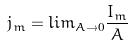<formula> <loc_0><loc_0><loc_500><loc_500>j _ { m } = l i m _ { A \rightarrow 0 } \frac { I _ { m } } { A }</formula> 